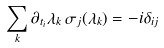<formula> <loc_0><loc_0><loc_500><loc_500>\sum _ { k } \partial _ { t _ { i } } \lambda _ { k } \, \sigma _ { j } ( \lambda _ { k } ) = - i \delta _ { i j }</formula> 